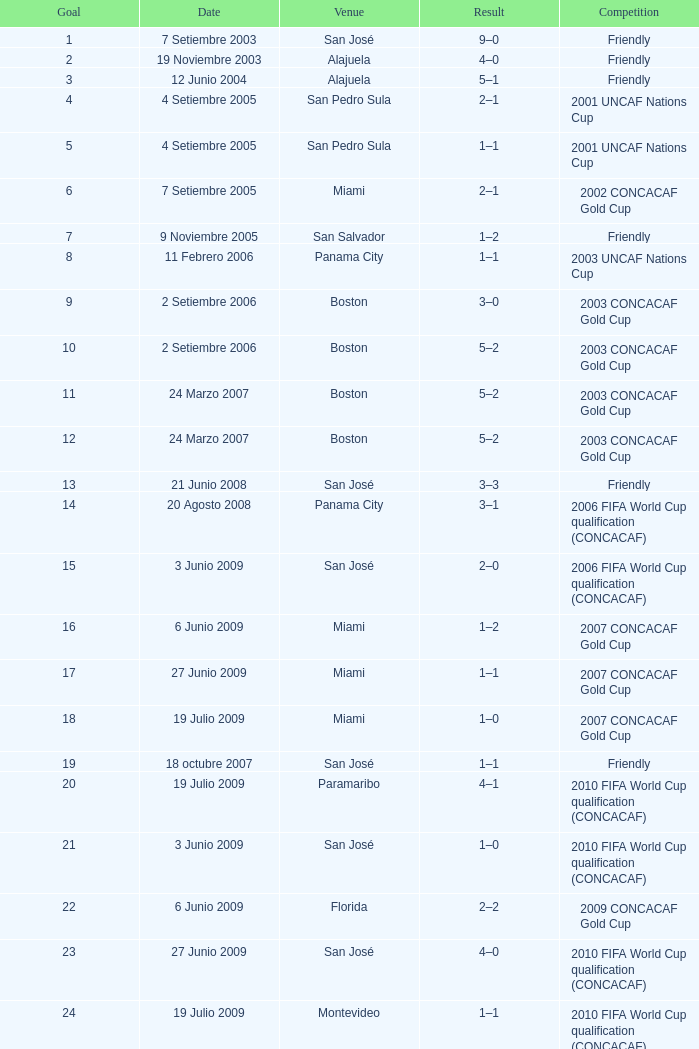How was the rivalry in which 6 goals were achieved? 2002 CONCACAF Gold Cup. 